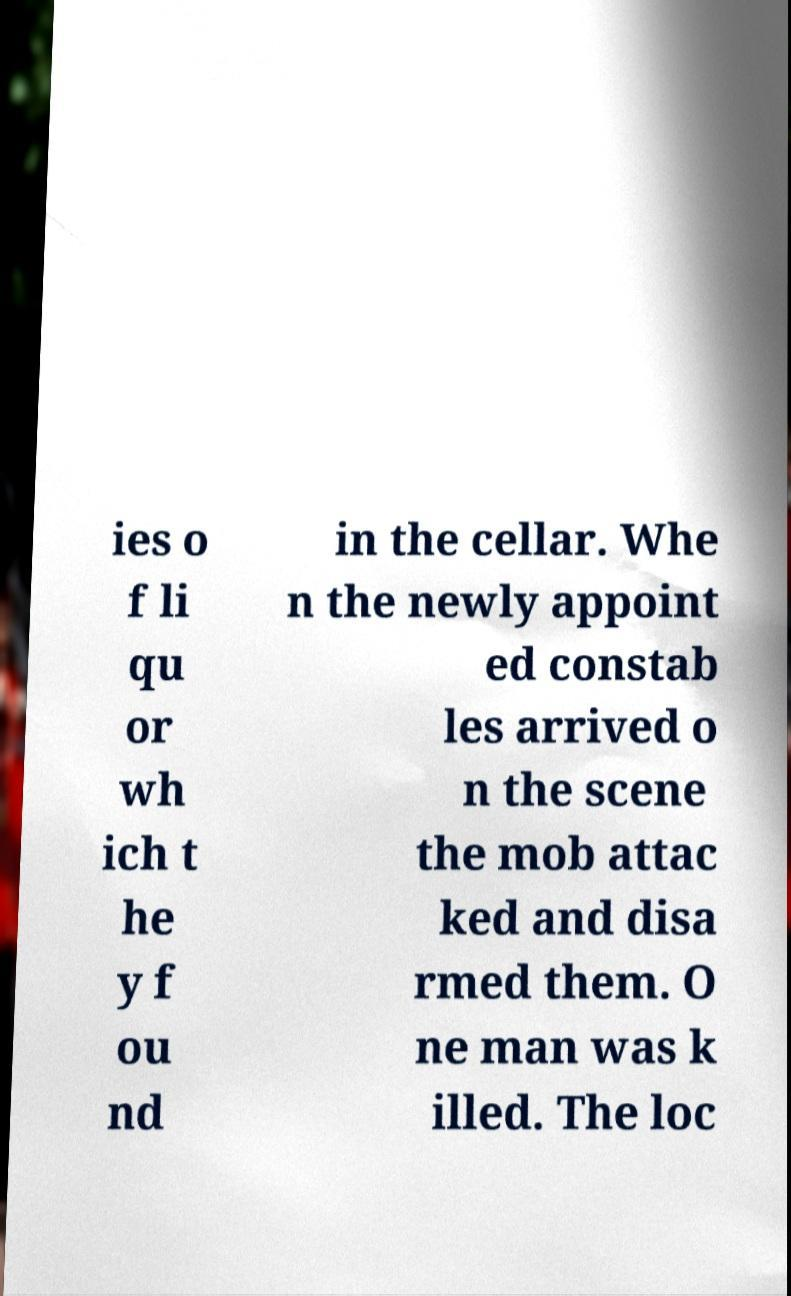I need the written content from this picture converted into text. Can you do that? ies o f li qu or wh ich t he y f ou nd in the cellar. Whe n the newly appoint ed constab les arrived o n the scene the mob attac ked and disa rmed them. O ne man was k illed. The loc 